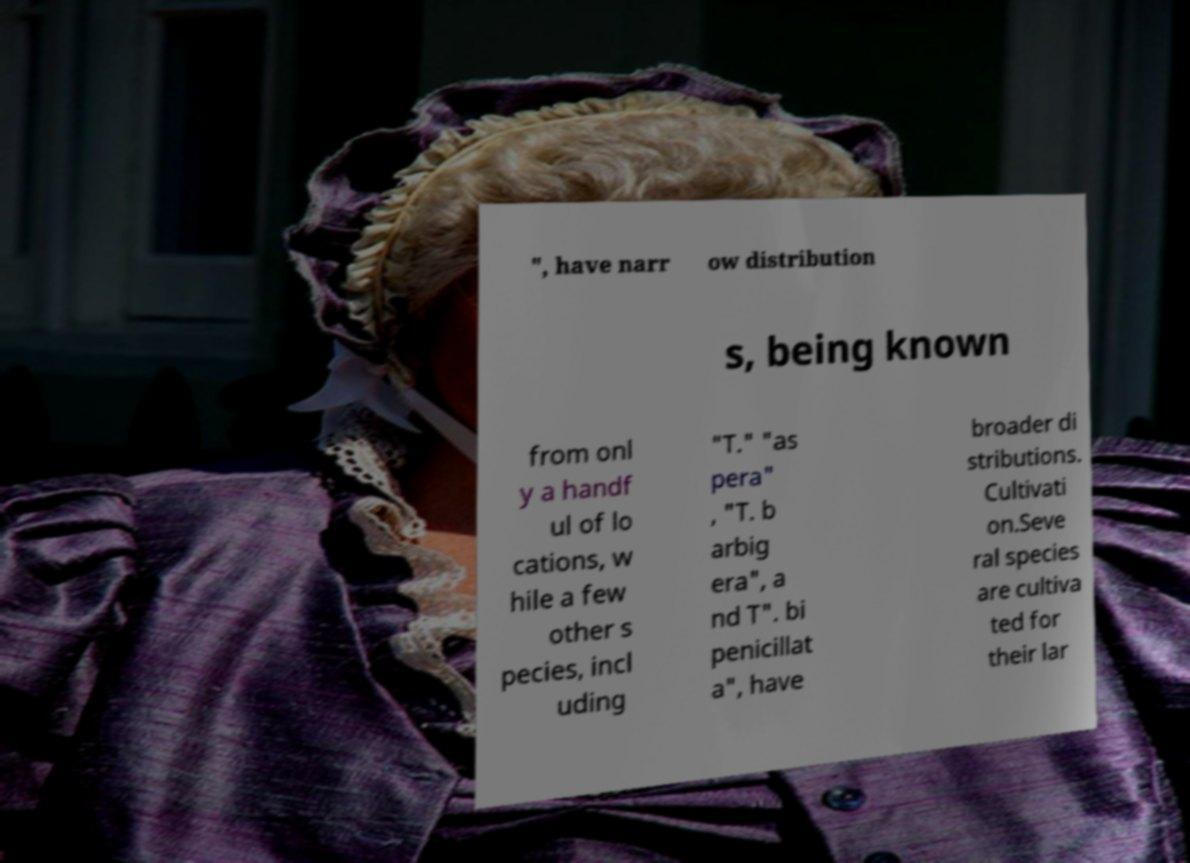Please read and relay the text visible in this image. What does it say? ", have narr ow distribution s, being known from onl y a handf ul of lo cations, w hile a few other s pecies, incl uding "T." "as pera" , "T. b arbig era", a nd T". bi penicillat a", have broader di stributions. Cultivati on.Seve ral species are cultiva ted for their lar 